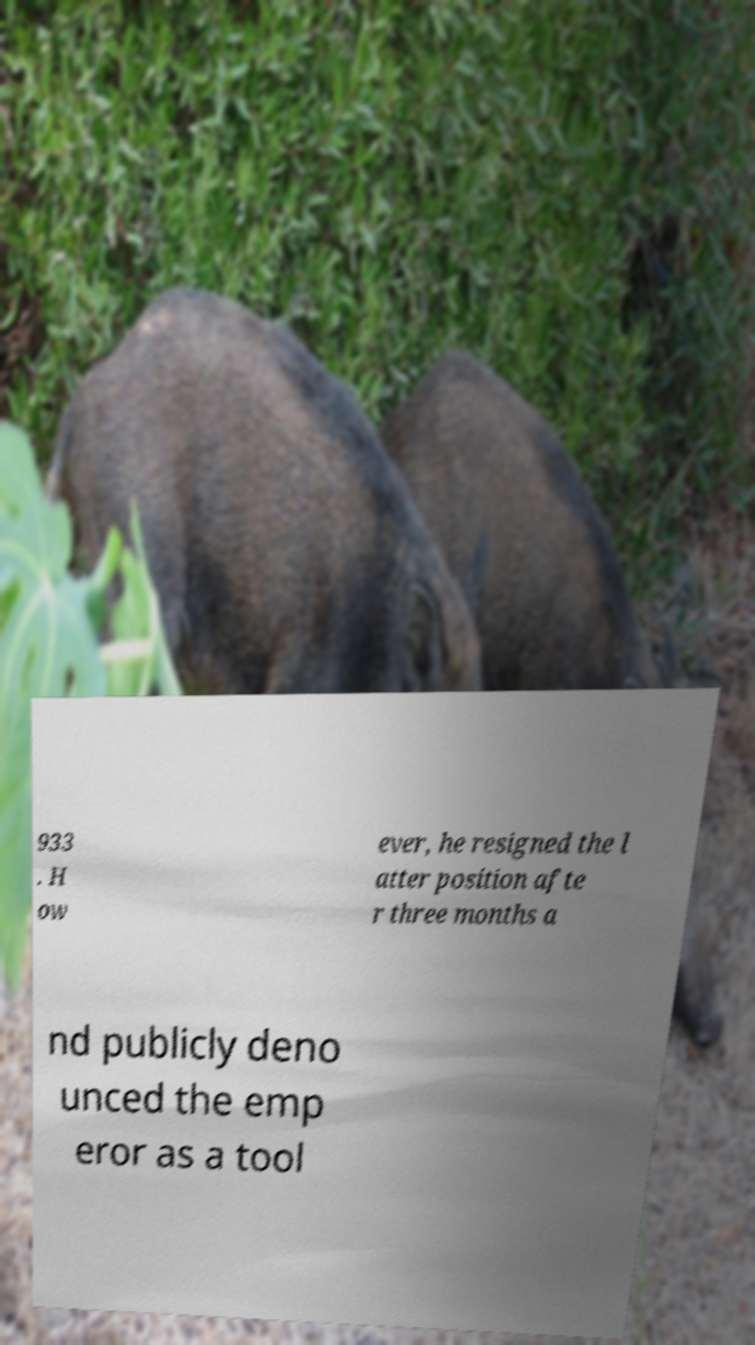Please identify and transcribe the text found in this image. 933 . H ow ever, he resigned the l atter position afte r three months a nd publicly deno unced the emp eror as a tool 